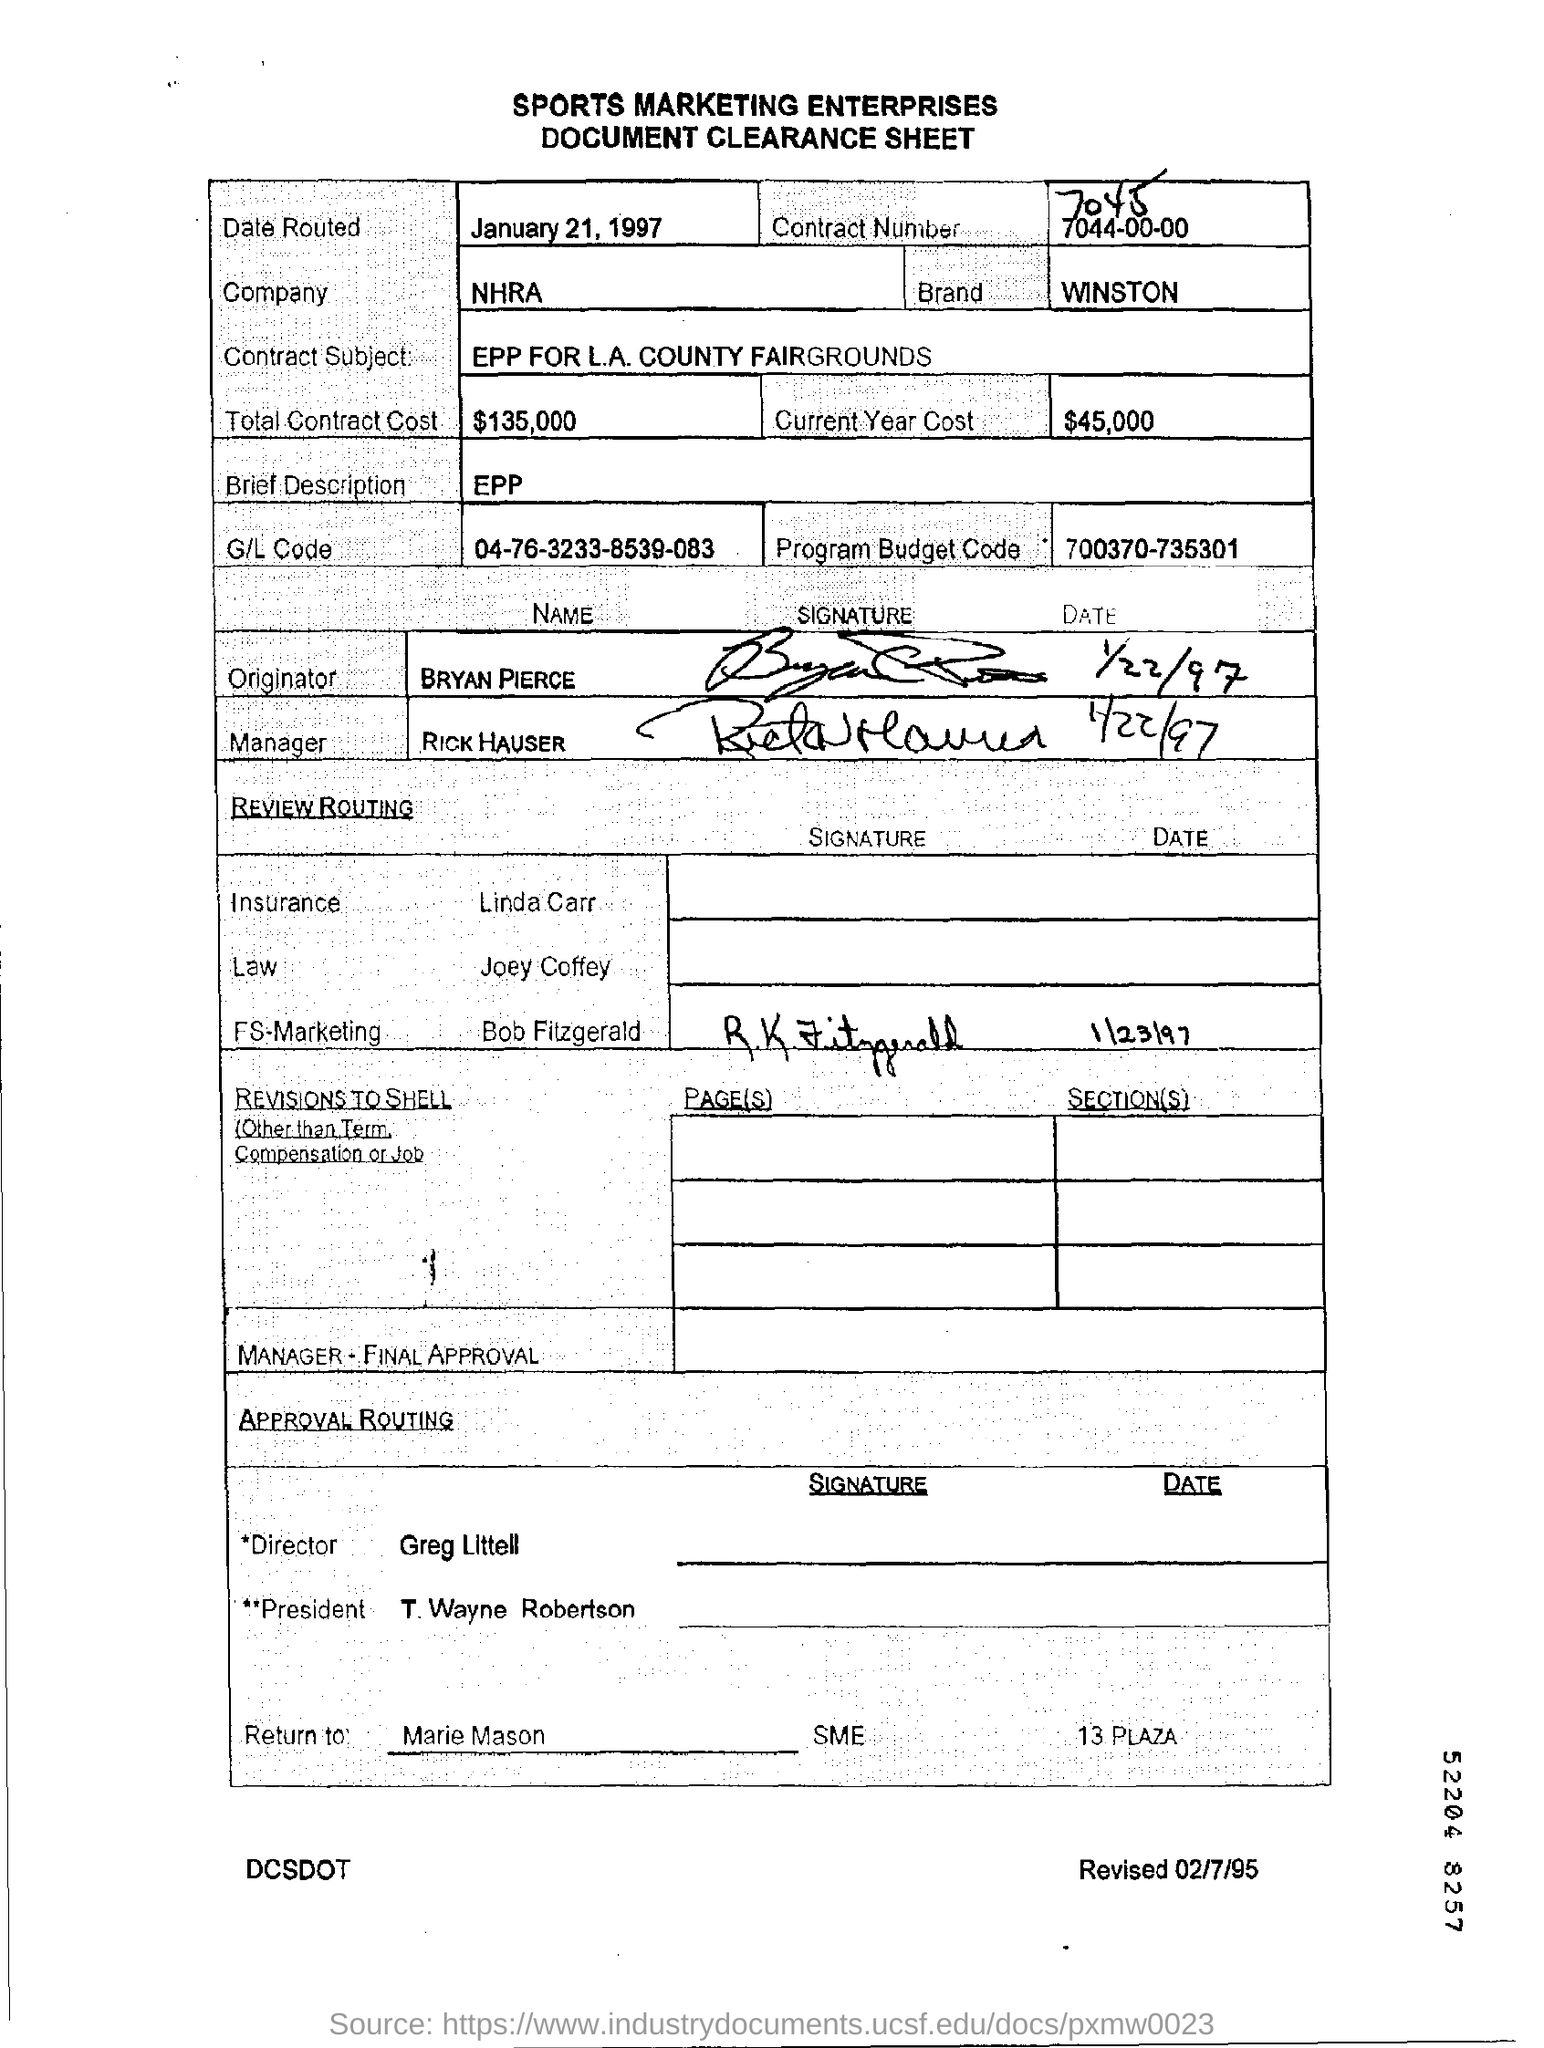Point out several critical features in this image. The date mentioned is January 21, 1997. The contract subject is "what is the L.A. COUNTY FAIRGROUNDS. The total contract cost is mentioned to be $135,000. The name of the company mentioned is NHRA. The program budget code mentioned is 700370-735301. 